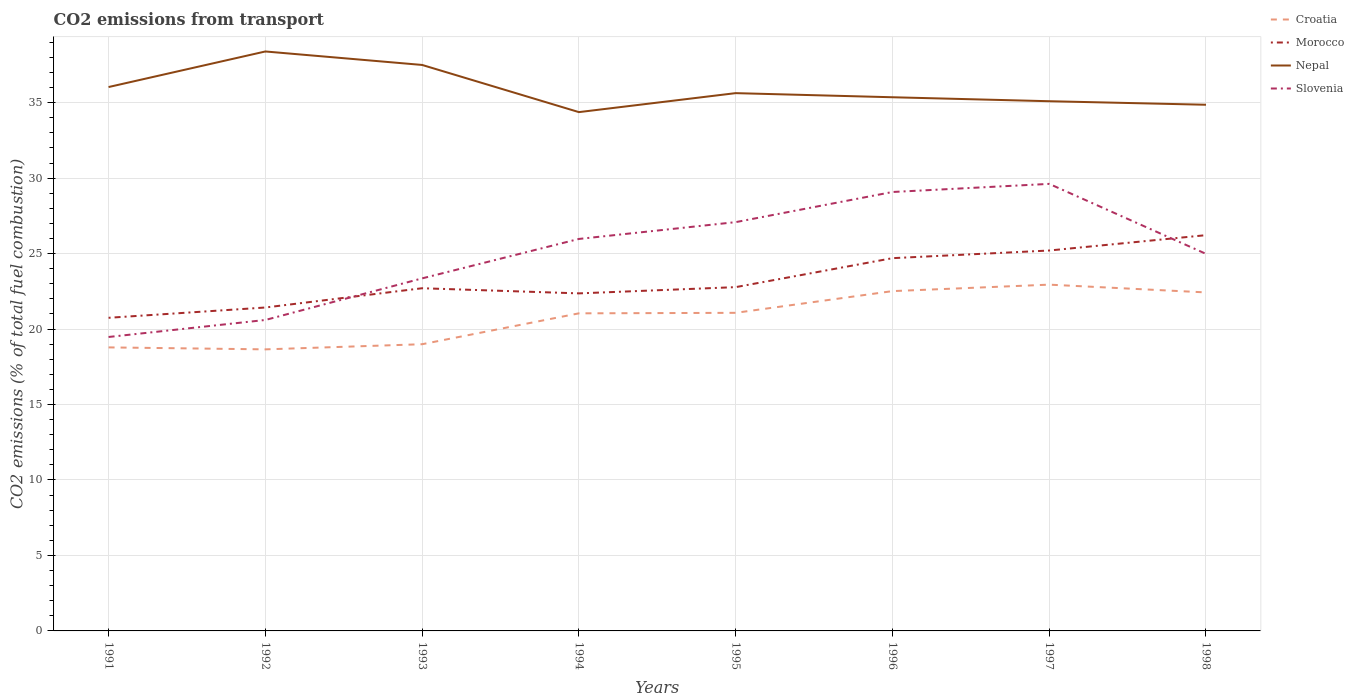How many different coloured lines are there?
Give a very brief answer. 4. Across all years, what is the maximum total CO2 emitted in Slovenia?
Your answer should be compact. 19.48. In which year was the total CO2 emitted in Nepal maximum?
Your response must be concise. 1994. What is the total total CO2 emitted in Morocco in the graph?
Your response must be concise. -1.35. What is the difference between the highest and the second highest total CO2 emitted in Croatia?
Your answer should be very brief. 4.29. Is the total CO2 emitted in Nepal strictly greater than the total CO2 emitted in Slovenia over the years?
Make the answer very short. No. How many lines are there?
Provide a short and direct response. 4. How many years are there in the graph?
Offer a very short reply. 8. Are the values on the major ticks of Y-axis written in scientific E-notation?
Keep it short and to the point. No. Does the graph contain grids?
Offer a very short reply. Yes. How are the legend labels stacked?
Your answer should be compact. Vertical. What is the title of the graph?
Your response must be concise. CO2 emissions from transport. What is the label or title of the Y-axis?
Make the answer very short. CO2 emissions (% of total fuel combustion). What is the CO2 emissions (% of total fuel combustion) in Croatia in 1991?
Offer a terse response. 18.79. What is the CO2 emissions (% of total fuel combustion) of Morocco in 1991?
Your answer should be very brief. 20.75. What is the CO2 emissions (% of total fuel combustion) of Nepal in 1991?
Make the answer very short. 36.04. What is the CO2 emissions (% of total fuel combustion) in Slovenia in 1991?
Provide a succinct answer. 19.48. What is the CO2 emissions (% of total fuel combustion) in Croatia in 1992?
Offer a very short reply. 18.66. What is the CO2 emissions (% of total fuel combustion) in Morocco in 1992?
Offer a very short reply. 21.43. What is the CO2 emissions (% of total fuel combustion) in Nepal in 1992?
Your answer should be compact. 38.39. What is the CO2 emissions (% of total fuel combustion) in Slovenia in 1992?
Keep it short and to the point. 20.6. What is the CO2 emissions (% of total fuel combustion) in Croatia in 1993?
Provide a short and direct response. 19. What is the CO2 emissions (% of total fuel combustion) of Morocco in 1993?
Your response must be concise. 22.71. What is the CO2 emissions (% of total fuel combustion) in Nepal in 1993?
Offer a very short reply. 37.5. What is the CO2 emissions (% of total fuel combustion) of Slovenia in 1993?
Make the answer very short. 23.36. What is the CO2 emissions (% of total fuel combustion) in Croatia in 1994?
Provide a succinct answer. 21.04. What is the CO2 emissions (% of total fuel combustion) in Morocco in 1994?
Keep it short and to the point. 22.36. What is the CO2 emissions (% of total fuel combustion) of Nepal in 1994?
Offer a terse response. 34.38. What is the CO2 emissions (% of total fuel combustion) of Slovenia in 1994?
Offer a terse response. 25.97. What is the CO2 emissions (% of total fuel combustion) of Croatia in 1995?
Provide a succinct answer. 21.08. What is the CO2 emissions (% of total fuel combustion) in Morocco in 1995?
Offer a terse response. 22.78. What is the CO2 emissions (% of total fuel combustion) of Nepal in 1995?
Give a very brief answer. 35.63. What is the CO2 emissions (% of total fuel combustion) of Slovenia in 1995?
Give a very brief answer. 27.08. What is the CO2 emissions (% of total fuel combustion) of Croatia in 1996?
Keep it short and to the point. 22.51. What is the CO2 emissions (% of total fuel combustion) in Morocco in 1996?
Your response must be concise. 24.7. What is the CO2 emissions (% of total fuel combustion) in Nepal in 1996?
Provide a short and direct response. 35.36. What is the CO2 emissions (% of total fuel combustion) in Slovenia in 1996?
Provide a succinct answer. 29.08. What is the CO2 emissions (% of total fuel combustion) of Croatia in 1997?
Ensure brevity in your answer.  22.94. What is the CO2 emissions (% of total fuel combustion) in Morocco in 1997?
Keep it short and to the point. 25.21. What is the CO2 emissions (% of total fuel combustion) of Nepal in 1997?
Offer a terse response. 35.1. What is the CO2 emissions (% of total fuel combustion) of Slovenia in 1997?
Offer a very short reply. 29.62. What is the CO2 emissions (% of total fuel combustion) in Croatia in 1998?
Give a very brief answer. 22.43. What is the CO2 emissions (% of total fuel combustion) of Morocco in 1998?
Ensure brevity in your answer.  26.22. What is the CO2 emissions (% of total fuel combustion) of Nepal in 1998?
Provide a succinct answer. 34.86. What is the CO2 emissions (% of total fuel combustion) in Slovenia in 1998?
Make the answer very short. 24.98. Across all years, what is the maximum CO2 emissions (% of total fuel combustion) in Croatia?
Keep it short and to the point. 22.94. Across all years, what is the maximum CO2 emissions (% of total fuel combustion) of Morocco?
Offer a very short reply. 26.22. Across all years, what is the maximum CO2 emissions (% of total fuel combustion) of Nepal?
Ensure brevity in your answer.  38.39. Across all years, what is the maximum CO2 emissions (% of total fuel combustion) in Slovenia?
Provide a short and direct response. 29.62. Across all years, what is the minimum CO2 emissions (% of total fuel combustion) of Croatia?
Your response must be concise. 18.66. Across all years, what is the minimum CO2 emissions (% of total fuel combustion) in Morocco?
Offer a very short reply. 20.75. Across all years, what is the minimum CO2 emissions (% of total fuel combustion) in Nepal?
Make the answer very short. 34.38. Across all years, what is the minimum CO2 emissions (% of total fuel combustion) in Slovenia?
Offer a terse response. 19.48. What is the total CO2 emissions (% of total fuel combustion) in Croatia in the graph?
Provide a succinct answer. 166.44. What is the total CO2 emissions (% of total fuel combustion) in Morocco in the graph?
Provide a short and direct response. 186.15. What is the total CO2 emissions (% of total fuel combustion) in Nepal in the graph?
Offer a very short reply. 287.25. What is the total CO2 emissions (% of total fuel combustion) of Slovenia in the graph?
Offer a terse response. 200.18. What is the difference between the CO2 emissions (% of total fuel combustion) in Croatia in 1991 and that in 1992?
Keep it short and to the point. 0.13. What is the difference between the CO2 emissions (% of total fuel combustion) in Morocco in 1991 and that in 1992?
Keep it short and to the point. -0.68. What is the difference between the CO2 emissions (% of total fuel combustion) of Nepal in 1991 and that in 1992?
Make the answer very short. -2.36. What is the difference between the CO2 emissions (% of total fuel combustion) of Slovenia in 1991 and that in 1992?
Provide a succinct answer. -1.13. What is the difference between the CO2 emissions (% of total fuel combustion) of Croatia in 1991 and that in 1993?
Your response must be concise. -0.21. What is the difference between the CO2 emissions (% of total fuel combustion) in Morocco in 1991 and that in 1993?
Your answer should be very brief. -1.96. What is the difference between the CO2 emissions (% of total fuel combustion) in Nepal in 1991 and that in 1993?
Make the answer very short. -1.46. What is the difference between the CO2 emissions (% of total fuel combustion) of Slovenia in 1991 and that in 1993?
Give a very brief answer. -3.88. What is the difference between the CO2 emissions (% of total fuel combustion) of Croatia in 1991 and that in 1994?
Ensure brevity in your answer.  -2.26. What is the difference between the CO2 emissions (% of total fuel combustion) of Morocco in 1991 and that in 1994?
Keep it short and to the point. -1.62. What is the difference between the CO2 emissions (% of total fuel combustion) of Nepal in 1991 and that in 1994?
Provide a succinct answer. 1.66. What is the difference between the CO2 emissions (% of total fuel combustion) of Slovenia in 1991 and that in 1994?
Offer a terse response. -6.5. What is the difference between the CO2 emissions (% of total fuel combustion) in Croatia in 1991 and that in 1995?
Make the answer very short. -2.29. What is the difference between the CO2 emissions (% of total fuel combustion) in Morocco in 1991 and that in 1995?
Your answer should be compact. -2.03. What is the difference between the CO2 emissions (% of total fuel combustion) of Nepal in 1991 and that in 1995?
Make the answer very short. 0.4. What is the difference between the CO2 emissions (% of total fuel combustion) of Slovenia in 1991 and that in 1995?
Provide a succinct answer. -7.61. What is the difference between the CO2 emissions (% of total fuel combustion) in Croatia in 1991 and that in 1996?
Offer a terse response. -3.73. What is the difference between the CO2 emissions (% of total fuel combustion) in Morocco in 1991 and that in 1996?
Provide a short and direct response. -3.95. What is the difference between the CO2 emissions (% of total fuel combustion) in Nepal in 1991 and that in 1996?
Provide a succinct answer. 0.68. What is the difference between the CO2 emissions (% of total fuel combustion) of Slovenia in 1991 and that in 1996?
Make the answer very short. -9.61. What is the difference between the CO2 emissions (% of total fuel combustion) in Croatia in 1991 and that in 1997?
Offer a terse response. -4.16. What is the difference between the CO2 emissions (% of total fuel combustion) in Morocco in 1991 and that in 1997?
Give a very brief answer. -4.46. What is the difference between the CO2 emissions (% of total fuel combustion) in Nepal in 1991 and that in 1997?
Keep it short and to the point. 0.94. What is the difference between the CO2 emissions (% of total fuel combustion) of Slovenia in 1991 and that in 1997?
Your answer should be compact. -10.14. What is the difference between the CO2 emissions (% of total fuel combustion) in Croatia in 1991 and that in 1998?
Your answer should be compact. -3.64. What is the difference between the CO2 emissions (% of total fuel combustion) in Morocco in 1991 and that in 1998?
Make the answer very short. -5.48. What is the difference between the CO2 emissions (% of total fuel combustion) of Nepal in 1991 and that in 1998?
Make the answer very short. 1.17. What is the difference between the CO2 emissions (% of total fuel combustion) in Slovenia in 1991 and that in 1998?
Provide a succinct answer. -5.51. What is the difference between the CO2 emissions (% of total fuel combustion) in Croatia in 1992 and that in 1993?
Offer a very short reply. -0.34. What is the difference between the CO2 emissions (% of total fuel combustion) of Morocco in 1992 and that in 1993?
Your answer should be compact. -1.28. What is the difference between the CO2 emissions (% of total fuel combustion) in Nepal in 1992 and that in 1993?
Your response must be concise. 0.89. What is the difference between the CO2 emissions (% of total fuel combustion) of Slovenia in 1992 and that in 1993?
Make the answer very short. -2.76. What is the difference between the CO2 emissions (% of total fuel combustion) in Croatia in 1992 and that in 1994?
Make the answer very short. -2.39. What is the difference between the CO2 emissions (% of total fuel combustion) of Morocco in 1992 and that in 1994?
Your response must be concise. -0.94. What is the difference between the CO2 emissions (% of total fuel combustion) of Nepal in 1992 and that in 1994?
Provide a short and direct response. 4.02. What is the difference between the CO2 emissions (% of total fuel combustion) of Slovenia in 1992 and that in 1994?
Give a very brief answer. -5.37. What is the difference between the CO2 emissions (% of total fuel combustion) in Croatia in 1992 and that in 1995?
Offer a terse response. -2.42. What is the difference between the CO2 emissions (% of total fuel combustion) in Morocco in 1992 and that in 1995?
Offer a very short reply. -1.35. What is the difference between the CO2 emissions (% of total fuel combustion) in Nepal in 1992 and that in 1995?
Make the answer very short. 2.76. What is the difference between the CO2 emissions (% of total fuel combustion) of Slovenia in 1992 and that in 1995?
Offer a terse response. -6.48. What is the difference between the CO2 emissions (% of total fuel combustion) in Croatia in 1992 and that in 1996?
Provide a succinct answer. -3.86. What is the difference between the CO2 emissions (% of total fuel combustion) of Morocco in 1992 and that in 1996?
Offer a very short reply. -3.27. What is the difference between the CO2 emissions (% of total fuel combustion) of Nepal in 1992 and that in 1996?
Your answer should be very brief. 3.03. What is the difference between the CO2 emissions (% of total fuel combustion) in Slovenia in 1992 and that in 1996?
Your answer should be very brief. -8.48. What is the difference between the CO2 emissions (% of total fuel combustion) in Croatia in 1992 and that in 1997?
Provide a succinct answer. -4.29. What is the difference between the CO2 emissions (% of total fuel combustion) in Morocco in 1992 and that in 1997?
Your answer should be very brief. -3.78. What is the difference between the CO2 emissions (% of total fuel combustion) of Nepal in 1992 and that in 1997?
Give a very brief answer. 3.3. What is the difference between the CO2 emissions (% of total fuel combustion) in Slovenia in 1992 and that in 1997?
Make the answer very short. -9.02. What is the difference between the CO2 emissions (% of total fuel combustion) in Croatia in 1992 and that in 1998?
Provide a succinct answer. -3.77. What is the difference between the CO2 emissions (% of total fuel combustion) in Morocco in 1992 and that in 1998?
Keep it short and to the point. -4.79. What is the difference between the CO2 emissions (% of total fuel combustion) of Nepal in 1992 and that in 1998?
Offer a very short reply. 3.53. What is the difference between the CO2 emissions (% of total fuel combustion) in Slovenia in 1992 and that in 1998?
Give a very brief answer. -4.38. What is the difference between the CO2 emissions (% of total fuel combustion) of Croatia in 1993 and that in 1994?
Provide a succinct answer. -2.05. What is the difference between the CO2 emissions (% of total fuel combustion) in Morocco in 1993 and that in 1994?
Offer a terse response. 0.34. What is the difference between the CO2 emissions (% of total fuel combustion) of Nepal in 1993 and that in 1994?
Make the answer very short. 3.12. What is the difference between the CO2 emissions (% of total fuel combustion) of Slovenia in 1993 and that in 1994?
Give a very brief answer. -2.61. What is the difference between the CO2 emissions (% of total fuel combustion) of Croatia in 1993 and that in 1995?
Make the answer very short. -2.08. What is the difference between the CO2 emissions (% of total fuel combustion) of Morocco in 1993 and that in 1995?
Keep it short and to the point. -0.07. What is the difference between the CO2 emissions (% of total fuel combustion) in Nepal in 1993 and that in 1995?
Make the answer very short. 1.87. What is the difference between the CO2 emissions (% of total fuel combustion) in Slovenia in 1993 and that in 1995?
Your answer should be very brief. -3.73. What is the difference between the CO2 emissions (% of total fuel combustion) in Croatia in 1993 and that in 1996?
Your answer should be very brief. -3.52. What is the difference between the CO2 emissions (% of total fuel combustion) in Morocco in 1993 and that in 1996?
Give a very brief answer. -1.99. What is the difference between the CO2 emissions (% of total fuel combustion) in Nepal in 1993 and that in 1996?
Offer a very short reply. 2.14. What is the difference between the CO2 emissions (% of total fuel combustion) in Slovenia in 1993 and that in 1996?
Provide a succinct answer. -5.72. What is the difference between the CO2 emissions (% of total fuel combustion) of Croatia in 1993 and that in 1997?
Offer a terse response. -3.95. What is the difference between the CO2 emissions (% of total fuel combustion) of Morocco in 1993 and that in 1997?
Make the answer very short. -2.5. What is the difference between the CO2 emissions (% of total fuel combustion) of Nepal in 1993 and that in 1997?
Provide a succinct answer. 2.4. What is the difference between the CO2 emissions (% of total fuel combustion) in Slovenia in 1993 and that in 1997?
Give a very brief answer. -6.26. What is the difference between the CO2 emissions (% of total fuel combustion) in Croatia in 1993 and that in 1998?
Your answer should be compact. -3.43. What is the difference between the CO2 emissions (% of total fuel combustion) of Morocco in 1993 and that in 1998?
Your response must be concise. -3.52. What is the difference between the CO2 emissions (% of total fuel combustion) in Nepal in 1993 and that in 1998?
Provide a short and direct response. 2.64. What is the difference between the CO2 emissions (% of total fuel combustion) of Slovenia in 1993 and that in 1998?
Your answer should be very brief. -1.62. What is the difference between the CO2 emissions (% of total fuel combustion) in Croatia in 1994 and that in 1995?
Offer a very short reply. -0.03. What is the difference between the CO2 emissions (% of total fuel combustion) in Morocco in 1994 and that in 1995?
Offer a terse response. -0.41. What is the difference between the CO2 emissions (% of total fuel combustion) of Nepal in 1994 and that in 1995?
Give a very brief answer. -1.26. What is the difference between the CO2 emissions (% of total fuel combustion) of Slovenia in 1994 and that in 1995?
Offer a terse response. -1.11. What is the difference between the CO2 emissions (% of total fuel combustion) of Croatia in 1994 and that in 1996?
Give a very brief answer. -1.47. What is the difference between the CO2 emissions (% of total fuel combustion) of Morocco in 1994 and that in 1996?
Offer a very short reply. -2.33. What is the difference between the CO2 emissions (% of total fuel combustion) of Nepal in 1994 and that in 1996?
Ensure brevity in your answer.  -0.98. What is the difference between the CO2 emissions (% of total fuel combustion) in Slovenia in 1994 and that in 1996?
Provide a succinct answer. -3.11. What is the difference between the CO2 emissions (% of total fuel combustion) of Croatia in 1994 and that in 1997?
Provide a short and direct response. -1.9. What is the difference between the CO2 emissions (% of total fuel combustion) of Morocco in 1994 and that in 1997?
Your answer should be very brief. -2.84. What is the difference between the CO2 emissions (% of total fuel combustion) in Nepal in 1994 and that in 1997?
Give a very brief answer. -0.72. What is the difference between the CO2 emissions (% of total fuel combustion) of Slovenia in 1994 and that in 1997?
Your answer should be very brief. -3.65. What is the difference between the CO2 emissions (% of total fuel combustion) of Croatia in 1994 and that in 1998?
Offer a very short reply. -1.39. What is the difference between the CO2 emissions (% of total fuel combustion) of Morocco in 1994 and that in 1998?
Your answer should be very brief. -3.86. What is the difference between the CO2 emissions (% of total fuel combustion) in Nepal in 1994 and that in 1998?
Your answer should be very brief. -0.49. What is the difference between the CO2 emissions (% of total fuel combustion) of Croatia in 1995 and that in 1996?
Provide a short and direct response. -1.44. What is the difference between the CO2 emissions (% of total fuel combustion) of Morocco in 1995 and that in 1996?
Provide a short and direct response. -1.92. What is the difference between the CO2 emissions (% of total fuel combustion) in Nepal in 1995 and that in 1996?
Give a very brief answer. 0.27. What is the difference between the CO2 emissions (% of total fuel combustion) of Slovenia in 1995 and that in 1996?
Your answer should be very brief. -2. What is the difference between the CO2 emissions (% of total fuel combustion) in Croatia in 1995 and that in 1997?
Your answer should be very brief. -1.87. What is the difference between the CO2 emissions (% of total fuel combustion) of Morocco in 1995 and that in 1997?
Provide a succinct answer. -2.43. What is the difference between the CO2 emissions (% of total fuel combustion) in Nepal in 1995 and that in 1997?
Provide a short and direct response. 0.54. What is the difference between the CO2 emissions (% of total fuel combustion) in Slovenia in 1995 and that in 1997?
Provide a short and direct response. -2.54. What is the difference between the CO2 emissions (% of total fuel combustion) in Croatia in 1995 and that in 1998?
Give a very brief answer. -1.35. What is the difference between the CO2 emissions (% of total fuel combustion) in Morocco in 1995 and that in 1998?
Your answer should be compact. -3.44. What is the difference between the CO2 emissions (% of total fuel combustion) in Nepal in 1995 and that in 1998?
Provide a short and direct response. 0.77. What is the difference between the CO2 emissions (% of total fuel combustion) of Slovenia in 1995 and that in 1998?
Keep it short and to the point. 2.1. What is the difference between the CO2 emissions (% of total fuel combustion) in Croatia in 1996 and that in 1997?
Your answer should be very brief. -0.43. What is the difference between the CO2 emissions (% of total fuel combustion) in Morocco in 1996 and that in 1997?
Provide a short and direct response. -0.51. What is the difference between the CO2 emissions (% of total fuel combustion) in Nepal in 1996 and that in 1997?
Keep it short and to the point. 0.26. What is the difference between the CO2 emissions (% of total fuel combustion) in Slovenia in 1996 and that in 1997?
Provide a succinct answer. -0.54. What is the difference between the CO2 emissions (% of total fuel combustion) of Croatia in 1996 and that in 1998?
Give a very brief answer. 0.09. What is the difference between the CO2 emissions (% of total fuel combustion) in Morocco in 1996 and that in 1998?
Your answer should be very brief. -1.52. What is the difference between the CO2 emissions (% of total fuel combustion) in Nepal in 1996 and that in 1998?
Offer a terse response. 0.5. What is the difference between the CO2 emissions (% of total fuel combustion) in Slovenia in 1996 and that in 1998?
Your answer should be compact. 4.1. What is the difference between the CO2 emissions (% of total fuel combustion) of Croatia in 1997 and that in 1998?
Ensure brevity in your answer.  0.52. What is the difference between the CO2 emissions (% of total fuel combustion) in Morocco in 1997 and that in 1998?
Offer a terse response. -1.02. What is the difference between the CO2 emissions (% of total fuel combustion) of Nepal in 1997 and that in 1998?
Offer a terse response. 0.23. What is the difference between the CO2 emissions (% of total fuel combustion) in Slovenia in 1997 and that in 1998?
Ensure brevity in your answer.  4.64. What is the difference between the CO2 emissions (% of total fuel combustion) of Croatia in 1991 and the CO2 emissions (% of total fuel combustion) of Morocco in 1992?
Make the answer very short. -2.64. What is the difference between the CO2 emissions (% of total fuel combustion) of Croatia in 1991 and the CO2 emissions (% of total fuel combustion) of Nepal in 1992?
Offer a very short reply. -19.61. What is the difference between the CO2 emissions (% of total fuel combustion) in Croatia in 1991 and the CO2 emissions (% of total fuel combustion) in Slovenia in 1992?
Your response must be concise. -1.82. What is the difference between the CO2 emissions (% of total fuel combustion) of Morocco in 1991 and the CO2 emissions (% of total fuel combustion) of Nepal in 1992?
Keep it short and to the point. -17.65. What is the difference between the CO2 emissions (% of total fuel combustion) of Morocco in 1991 and the CO2 emissions (% of total fuel combustion) of Slovenia in 1992?
Offer a terse response. 0.14. What is the difference between the CO2 emissions (% of total fuel combustion) in Nepal in 1991 and the CO2 emissions (% of total fuel combustion) in Slovenia in 1992?
Provide a short and direct response. 15.43. What is the difference between the CO2 emissions (% of total fuel combustion) in Croatia in 1991 and the CO2 emissions (% of total fuel combustion) in Morocco in 1993?
Your answer should be compact. -3.92. What is the difference between the CO2 emissions (% of total fuel combustion) of Croatia in 1991 and the CO2 emissions (% of total fuel combustion) of Nepal in 1993?
Make the answer very short. -18.71. What is the difference between the CO2 emissions (% of total fuel combustion) in Croatia in 1991 and the CO2 emissions (% of total fuel combustion) in Slovenia in 1993?
Ensure brevity in your answer.  -4.57. What is the difference between the CO2 emissions (% of total fuel combustion) of Morocco in 1991 and the CO2 emissions (% of total fuel combustion) of Nepal in 1993?
Give a very brief answer. -16.75. What is the difference between the CO2 emissions (% of total fuel combustion) of Morocco in 1991 and the CO2 emissions (% of total fuel combustion) of Slovenia in 1993?
Your response must be concise. -2.61. What is the difference between the CO2 emissions (% of total fuel combustion) in Nepal in 1991 and the CO2 emissions (% of total fuel combustion) in Slovenia in 1993?
Your answer should be compact. 12.68. What is the difference between the CO2 emissions (% of total fuel combustion) of Croatia in 1991 and the CO2 emissions (% of total fuel combustion) of Morocco in 1994?
Provide a short and direct response. -3.58. What is the difference between the CO2 emissions (% of total fuel combustion) in Croatia in 1991 and the CO2 emissions (% of total fuel combustion) in Nepal in 1994?
Offer a very short reply. -15.59. What is the difference between the CO2 emissions (% of total fuel combustion) of Croatia in 1991 and the CO2 emissions (% of total fuel combustion) of Slovenia in 1994?
Offer a very short reply. -7.19. What is the difference between the CO2 emissions (% of total fuel combustion) in Morocco in 1991 and the CO2 emissions (% of total fuel combustion) in Nepal in 1994?
Keep it short and to the point. -13.63. What is the difference between the CO2 emissions (% of total fuel combustion) of Morocco in 1991 and the CO2 emissions (% of total fuel combustion) of Slovenia in 1994?
Make the answer very short. -5.22. What is the difference between the CO2 emissions (% of total fuel combustion) of Nepal in 1991 and the CO2 emissions (% of total fuel combustion) of Slovenia in 1994?
Give a very brief answer. 10.06. What is the difference between the CO2 emissions (% of total fuel combustion) of Croatia in 1991 and the CO2 emissions (% of total fuel combustion) of Morocco in 1995?
Provide a short and direct response. -3.99. What is the difference between the CO2 emissions (% of total fuel combustion) of Croatia in 1991 and the CO2 emissions (% of total fuel combustion) of Nepal in 1995?
Offer a very short reply. -16.85. What is the difference between the CO2 emissions (% of total fuel combustion) of Croatia in 1991 and the CO2 emissions (% of total fuel combustion) of Slovenia in 1995?
Offer a very short reply. -8.3. What is the difference between the CO2 emissions (% of total fuel combustion) in Morocco in 1991 and the CO2 emissions (% of total fuel combustion) in Nepal in 1995?
Make the answer very short. -14.89. What is the difference between the CO2 emissions (% of total fuel combustion) of Morocco in 1991 and the CO2 emissions (% of total fuel combustion) of Slovenia in 1995?
Your response must be concise. -6.34. What is the difference between the CO2 emissions (% of total fuel combustion) in Nepal in 1991 and the CO2 emissions (% of total fuel combustion) in Slovenia in 1995?
Keep it short and to the point. 8.95. What is the difference between the CO2 emissions (% of total fuel combustion) of Croatia in 1991 and the CO2 emissions (% of total fuel combustion) of Morocco in 1996?
Give a very brief answer. -5.91. What is the difference between the CO2 emissions (% of total fuel combustion) of Croatia in 1991 and the CO2 emissions (% of total fuel combustion) of Nepal in 1996?
Provide a succinct answer. -16.57. What is the difference between the CO2 emissions (% of total fuel combustion) of Croatia in 1991 and the CO2 emissions (% of total fuel combustion) of Slovenia in 1996?
Provide a succinct answer. -10.3. What is the difference between the CO2 emissions (% of total fuel combustion) in Morocco in 1991 and the CO2 emissions (% of total fuel combustion) in Nepal in 1996?
Your response must be concise. -14.61. What is the difference between the CO2 emissions (% of total fuel combustion) of Morocco in 1991 and the CO2 emissions (% of total fuel combustion) of Slovenia in 1996?
Make the answer very short. -8.34. What is the difference between the CO2 emissions (% of total fuel combustion) of Nepal in 1991 and the CO2 emissions (% of total fuel combustion) of Slovenia in 1996?
Offer a terse response. 6.95. What is the difference between the CO2 emissions (% of total fuel combustion) in Croatia in 1991 and the CO2 emissions (% of total fuel combustion) in Morocco in 1997?
Your answer should be compact. -6.42. What is the difference between the CO2 emissions (% of total fuel combustion) of Croatia in 1991 and the CO2 emissions (% of total fuel combustion) of Nepal in 1997?
Your response must be concise. -16.31. What is the difference between the CO2 emissions (% of total fuel combustion) in Croatia in 1991 and the CO2 emissions (% of total fuel combustion) in Slovenia in 1997?
Offer a terse response. -10.83. What is the difference between the CO2 emissions (% of total fuel combustion) of Morocco in 1991 and the CO2 emissions (% of total fuel combustion) of Nepal in 1997?
Provide a succinct answer. -14.35. What is the difference between the CO2 emissions (% of total fuel combustion) of Morocco in 1991 and the CO2 emissions (% of total fuel combustion) of Slovenia in 1997?
Offer a terse response. -8.87. What is the difference between the CO2 emissions (% of total fuel combustion) of Nepal in 1991 and the CO2 emissions (% of total fuel combustion) of Slovenia in 1997?
Your response must be concise. 6.42. What is the difference between the CO2 emissions (% of total fuel combustion) in Croatia in 1991 and the CO2 emissions (% of total fuel combustion) in Morocco in 1998?
Keep it short and to the point. -7.44. What is the difference between the CO2 emissions (% of total fuel combustion) of Croatia in 1991 and the CO2 emissions (% of total fuel combustion) of Nepal in 1998?
Keep it short and to the point. -16.08. What is the difference between the CO2 emissions (% of total fuel combustion) in Croatia in 1991 and the CO2 emissions (% of total fuel combustion) in Slovenia in 1998?
Keep it short and to the point. -6.2. What is the difference between the CO2 emissions (% of total fuel combustion) of Morocco in 1991 and the CO2 emissions (% of total fuel combustion) of Nepal in 1998?
Give a very brief answer. -14.12. What is the difference between the CO2 emissions (% of total fuel combustion) in Morocco in 1991 and the CO2 emissions (% of total fuel combustion) in Slovenia in 1998?
Keep it short and to the point. -4.24. What is the difference between the CO2 emissions (% of total fuel combustion) of Nepal in 1991 and the CO2 emissions (% of total fuel combustion) of Slovenia in 1998?
Make the answer very short. 11.05. What is the difference between the CO2 emissions (% of total fuel combustion) of Croatia in 1992 and the CO2 emissions (% of total fuel combustion) of Morocco in 1993?
Your response must be concise. -4.05. What is the difference between the CO2 emissions (% of total fuel combustion) of Croatia in 1992 and the CO2 emissions (% of total fuel combustion) of Nepal in 1993?
Your answer should be very brief. -18.84. What is the difference between the CO2 emissions (% of total fuel combustion) in Croatia in 1992 and the CO2 emissions (% of total fuel combustion) in Slovenia in 1993?
Keep it short and to the point. -4.7. What is the difference between the CO2 emissions (% of total fuel combustion) in Morocco in 1992 and the CO2 emissions (% of total fuel combustion) in Nepal in 1993?
Your answer should be very brief. -16.07. What is the difference between the CO2 emissions (% of total fuel combustion) in Morocco in 1992 and the CO2 emissions (% of total fuel combustion) in Slovenia in 1993?
Make the answer very short. -1.93. What is the difference between the CO2 emissions (% of total fuel combustion) of Nepal in 1992 and the CO2 emissions (% of total fuel combustion) of Slovenia in 1993?
Your response must be concise. 15.03. What is the difference between the CO2 emissions (% of total fuel combustion) in Croatia in 1992 and the CO2 emissions (% of total fuel combustion) in Morocco in 1994?
Ensure brevity in your answer.  -3.71. What is the difference between the CO2 emissions (% of total fuel combustion) of Croatia in 1992 and the CO2 emissions (% of total fuel combustion) of Nepal in 1994?
Offer a very short reply. -15.72. What is the difference between the CO2 emissions (% of total fuel combustion) in Croatia in 1992 and the CO2 emissions (% of total fuel combustion) in Slovenia in 1994?
Keep it short and to the point. -7.32. What is the difference between the CO2 emissions (% of total fuel combustion) in Morocco in 1992 and the CO2 emissions (% of total fuel combustion) in Nepal in 1994?
Provide a short and direct response. -12.95. What is the difference between the CO2 emissions (% of total fuel combustion) of Morocco in 1992 and the CO2 emissions (% of total fuel combustion) of Slovenia in 1994?
Provide a succinct answer. -4.54. What is the difference between the CO2 emissions (% of total fuel combustion) in Nepal in 1992 and the CO2 emissions (% of total fuel combustion) in Slovenia in 1994?
Offer a terse response. 12.42. What is the difference between the CO2 emissions (% of total fuel combustion) in Croatia in 1992 and the CO2 emissions (% of total fuel combustion) in Morocco in 1995?
Your answer should be compact. -4.12. What is the difference between the CO2 emissions (% of total fuel combustion) of Croatia in 1992 and the CO2 emissions (% of total fuel combustion) of Nepal in 1995?
Your answer should be compact. -16.98. What is the difference between the CO2 emissions (% of total fuel combustion) in Croatia in 1992 and the CO2 emissions (% of total fuel combustion) in Slovenia in 1995?
Provide a succinct answer. -8.43. What is the difference between the CO2 emissions (% of total fuel combustion) of Morocco in 1992 and the CO2 emissions (% of total fuel combustion) of Nepal in 1995?
Your answer should be very brief. -14.2. What is the difference between the CO2 emissions (% of total fuel combustion) in Morocco in 1992 and the CO2 emissions (% of total fuel combustion) in Slovenia in 1995?
Provide a short and direct response. -5.66. What is the difference between the CO2 emissions (% of total fuel combustion) of Nepal in 1992 and the CO2 emissions (% of total fuel combustion) of Slovenia in 1995?
Your answer should be compact. 11.31. What is the difference between the CO2 emissions (% of total fuel combustion) in Croatia in 1992 and the CO2 emissions (% of total fuel combustion) in Morocco in 1996?
Give a very brief answer. -6.04. What is the difference between the CO2 emissions (% of total fuel combustion) of Croatia in 1992 and the CO2 emissions (% of total fuel combustion) of Nepal in 1996?
Give a very brief answer. -16.7. What is the difference between the CO2 emissions (% of total fuel combustion) in Croatia in 1992 and the CO2 emissions (% of total fuel combustion) in Slovenia in 1996?
Make the answer very short. -10.43. What is the difference between the CO2 emissions (% of total fuel combustion) in Morocco in 1992 and the CO2 emissions (% of total fuel combustion) in Nepal in 1996?
Give a very brief answer. -13.93. What is the difference between the CO2 emissions (% of total fuel combustion) in Morocco in 1992 and the CO2 emissions (% of total fuel combustion) in Slovenia in 1996?
Keep it short and to the point. -7.65. What is the difference between the CO2 emissions (% of total fuel combustion) in Nepal in 1992 and the CO2 emissions (% of total fuel combustion) in Slovenia in 1996?
Give a very brief answer. 9.31. What is the difference between the CO2 emissions (% of total fuel combustion) in Croatia in 1992 and the CO2 emissions (% of total fuel combustion) in Morocco in 1997?
Ensure brevity in your answer.  -6.55. What is the difference between the CO2 emissions (% of total fuel combustion) in Croatia in 1992 and the CO2 emissions (% of total fuel combustion) in Nepal in 1997?
Give a very brief answer. -16.44. What is the difference between the CO2 emissions (% of total fuel combustion) of Croatia in 1992 and the CO2 emissions (% of total fuel combustion) of Slovenia in 1997?
Your response must be concise. -10.96. What is the difference between the CO2 emissions (% of total fuel combustion) in Morocco in 1992 and the CO2 emissions (% of total fuel combustion) in Nepal in 1997?
Your response must be concise. -13.67. What is the difference between the CO2 emissions (% of total fuel combustion) of Morocco in 1992 and the CO2 emissions (% of total fuel combustion) of Slovenia in 1997?
Offer a very short reply. -8.19. What is the difference between the CO2 emissions (% of total fuel combustion) in Nepal in 1992 and the CO2 emissions (% of total fuel combustion) in Slovenia in 1997?
Offer a very short reply. 8.77. What is the difference between the CO2 emissions (% of total fuel combustion) in Croatia in 1992 and the CO2 emissions (% of total fuel combustion) in Morocco in 1998?
Your response must be concise. -7.57. What is the difference between the CO2 emissions (% of total fuel combustion) of Croatia in 1992 and the CO2 emissions (% of total fuel combustion) of Nepal in 1998?
Provide a short and direct response. -16.21. What is the difference between the CO2 emissions (% of total fuel combustion) of Croatia in 1992 and the CO2 emissions (% of total fuel combustion) of Slovenia in 1998?
Your answer should be very brief. -6.33. What is the difference between the CO2 emissions (% of total fuel combustion) in Morocco in 1992 and the CO2 emissions (% of total fuel combustion) in Nepal in 1998?
Make the answer very short. -13.43. What is the difference between the CO2 emissions (% of total fuel combustion) in Morocco in 1992 and the CO2 emissions (% of total fuel combustion) in Slovenia in 1998?
Keep it short and to the point. -3.55. What is the difference between the CO2 emissions (% of total fuel combustion) of Nepal in 1992 and the CO2 emissions (% of total fuel combustion) of Slovenia in 1998?
Keep it short and to the point. 13.41. What is the difference between the CO2 emissions (% of total fuel combustion) of Croatia in 1993 and the CO2 emissions (% of total fuel combustion) of Morocco in 1994?
Your answer should be very brief. -3.37. What is the difference between the CO2 emissions (% of total fuel combustion) in Croatia in 1993 and the CO2 emissions (% of total fuel combustion) in Nepal in 1994?
Offer a terse response. -15.38. What is the difference between the CO2 emissions (% of total fuel combustion) of Croatia in 1993 and the CO2 emissions (% of total fuel combustion) of Slovenia in 1994?
Ensure brevity in your answer.  -6.97. What is the difference between the CO2 emissions (% of total fuel combustion) in Morocco in 1993 and the CO2 emissions (% of total fuel combustion) in Nepal in 1994?
Offer a very short reply. -11.67. What is the difference between the CO2 emissions (% of total fuel combustion) of Morocco in 1993 and the CO2 emissions (% of total fuel combustion) of Slovenia in 1994?
Your answer should be compact. -3.27. What is the difference between the CO2 emissions (% of total fuel combustion) of Nepal in 1993 and the CO2 emissions (% of total fuel combustion) of Slovenia in 1994?
Provide a succinct answer. 11.53. What is the difference between the CO2 emissions (% of total fuel combustion) of Croatia in 1993 and the CO2 emissions (% of total fuel combustion) of Morocco in 1995?
Ensure brevity in your answer.  -3.78. What is the difference between the CO2 emissions (% of total fuel combustion) of Croatia in 1993 and the CO2 emissions (% of total fuel combustion) of Nepal in 1995?
Keep it short and to the point. -16.64. What is the difference between the CO2 emissions (% of total fuel combustion) of Croatia in 1993 and the CO2 emissions (% of total fuel combustion) of Slovenia in 1995?
Keep it short and to the point. -8.09. What is the difference between the CO2 emissions (% of total fuel combustion) in Morocco in 1993 and the CO2 emissions (% of total fuel combustion) in Nepal in 1995?
Your answer should be compact. -12.93. What is the difference between the CO2 emissions (% of total fuel combustion) of Morocco in 1993 and the CO2 emissions (% of total fuel combustion) of Slovenia in 1995?
Provide a succinct answer. -4.38. What is the difference between the CO2 emissions (% of total fuel combustion) in Nepal in 1993 and the CO2 emissions (% of total fuel combustion) in Slovenia in 1995?
Ensure brevity in your answer.  10.42. What is the difference between the CO2 emissions (% of total fuel combustion) of Croatia in 1993 and the CO2 emissions (% of total fuel combustion) of Morocco in 1996?
Your answer should be very brief. -5.7. What is the difference between the CO2 emissions (% of total fuel combustion) of Croatia in 1993 and the CO2 emissions (% of total fuel combustion) of Nepal in 1996?
Provide a succinct answer. -16.36. What is the difference between the CO2 emissions (% of total fuel combustion) in Croatia in 1993 and the CO2 emissions (% of total fuel combustion) in Slovenia in 1996?
Your answer should be compact. -10.09. What is the difference between the CO2 emissions (% of total fuel combustion) in Morocco in 1993 and the CO2 emissions (% of total fuel combustion) in Nepal in 1996?
Ensure brevity in your answer.  -12.65. What is the difference between the CO2 emissions (% of total fuel combustion) of Morocco in 1993 and the CO2 emissions (% of total fuel combustion) of Slovenia in 1996?
Offer a very short reply. -6.38. What is the difference between the CO2 emissions (% of total fuel combustion) of Nepal in 1993 and the CO2 emissions (% of total fuel combustion) of Slovenia in 1996?
Your answer should be compact. 8.42. What is the difference between the CO2 emissions (% of total fuel combustion) of Croatia in 1993 and the CO2 emissions (% of total fuel combustion) of Morocco in 1997?
Give a very brief answer. -6.21. What is the difference between the CO2 emissions (% of total fuel combustion) in Croatia in 1993 and the CO2 emissions (% of total fuel combustion) in Nepal in 1997?
Provide a succinct answer. -16.1. What is the difference between the CO2 emissions (% of total fuel combustion) of Croatia in 1993 and the CO2 emissions (% of total fuel combustion) of Slovenia in 1997?
Provide a succinct answer. -10.62. What is the difference between the CO2 emissions (% of total fuel combustion) in Morocco in 1993 and the CO2 emissions (% of total fuel combustion) in Nepal in 1997?
Provide a short and direct response. -12.39. What is the difference between the CO2 emissions (% of total fuel combustion) of Morocco in 1993 and the CO2 emissions (% of total fuel combustion) of Slovenia in 1997?
Offer a terse response. -6.91. What is the difference between the CO2 emissions (% of total fuel combustion) of Nepal in 1993 and the CO2 emissions (% of total fuel combustion) of Slovenia in 1997?
Provide a succinct answer. 7.88. What is the difference between the CO2 emissions (% of total fuel combustion) of Croatia in 1993 and the CO2 emissions (% of total fuel combustion) of Morocco in 1998?
Keep it short and to the point. -7.23. What is the difference between the CO2 emissions (% of total fuel combustion) in Croatia in 1993 and the CO2 emissions (% of total fuel combustion) in Nepal in 1998?
Keep it short and to the point. -15.87. What is the difference between the CO2 emissions (% of total fuel combustion) in Croatia in 1993 and the CO2 emissions (% of total fuel combustion) in Slovenia in 1998?
Give a very brief answer. -5.99. What is the difference between the CO2 emissions (% of total fuel combustion) in Morocco in 1993 and the CO2 emissions (% of total fuel combustion) in Nepal in 1998?
Your answer should be very brief. -12.16. What is the difference between the CO2 emissions (% of total fuel combustion) in Morocco in 1993 and the CO2 emissions (% of total fuel combustion) in Slovenia in 1998?
Your answer should be very brief. -2.28. What is the difference between the CO2 emissions (% of total fuel combustion) in Nepal in 1993 and the CO2 emissions (% of total fuel combustion) in Slovenia in 1998?
Give a very brief answer. 12.52. What is the difference between the CO2 emissions (% of total fuel combustion) of Croatia in 1994 and the CO2 emissions (% of total fuel combustion) of Morocco in 1995?
Offer a terse response. -1.74. What is the difference between the CO2 emissions (% of total fuel combustion) in Croatia in 1994 and the CO2 emissions (% of total fuel combustion) in Nepal in 1995?
Your answer should be compact. -14.59. What is the difference between the CO2 emissions (% of total fuel combustion) of Croatia in 1994 and the CO2 emissions (% of total fuel combustion) of Slovenia in 1995?
Make the answer very short. -6.04. What is the difference between the CO2 emissions (% of total fuel combustion) in Morocco in 1994 and the CO2 emissions (% of total fuel combustion) in Nepal in 1995?
Provide a succinct answer. -13.27. What is the difference between the CO2 emissions (% of total fuel combustion) of Morocco in 1994 and the CO2 emissions (% of total fuel combustion) of Slovenia in 1995?
Your answer should be compact. -4.72. What is the difference between the CO2 emissions (% of total fuel combustion) of Nepal in 1994 and the CO2 emissions (% of total fuel combustion) of Slovenia in 1995?
Your answer should be compact. 7.29. What is the difference between the CO2 emissions (% of total fuel combustion) in Croatia in 1994 and the CO2 emissions (% of total fuel combustion) in Morocco in 1996?
Give a very brief answer. -3.66. What is the difference between the CO2 emissions (% of total fuel combustion) in Croatia in 1994 and the CO2 emissions (% of total fuel combustion) in Nepal in 1996?
Your answer should be compact. -14.32. What is the difference between the CO2 emissions (% of total fuel combustion) of Croatia in 1994 and the CO2 emissions (% of total fuel combustion) of Slovenia in 1996?
Ensure brevity in your answer.  -8.04. What is the difference between the CO2 emissions (% of total fuel combustion) of Morocco in 1994 and the CO2 emissions (% of total fuel combustion) of Nepal in 1996?
Your answer should be compact. -12.99. What is the difference between the CO2 emissions (% of total fuel combustion) in Morocco in 1994 and the CO2 emissions (% of total fuel combustion) in Slovenia in 1996?
Provide a succinct answer. -6.72. What is the difference between the CO2 emissions (% of total fuel combustion) in Nepal in 1994 and the CO2 emissions (% of total fuel combustion) in Slovenia in 1996?
Your answer should be compact. 5.29. What is the difference between the CO2 emissions (% of total fuel combustion) in Croatia in 1994 and the CO2 emissions (% of total fuel combustion) in Morocco in 1997?
Make the answer very short. -4.16. What is the difference between the CO2 emissions (% of total fuel combustion) in Croatia in 1994 and the CO2 emissions (% of total fuel combustion) in Nepal in 1997?
Provide a succinct answer. -14.05. What is the difference between the CO2 emissions (% of total fuel combustion) of Croatia in 1994 and the CO2 emissions (% of total fuel combustion) of Slovenia in 1997?
Your answer should be compact. -8.58. What is the difference between the CO2 emissions (% of total fuel combustion) in Morocco in 1994 and the CO2 emissions (% of total fuel combustion) in Nepal in 1997?
Your response must be concise. -12.73. What is the difference between the CO2 emissions (% of total fuel combustion) in Morocco in 1994 and the CO2 emissions (% of total fuel combustion) in Slovenia in 1997?
Ensure brevity in your answer.  -7.26. What is the difference between the CO2 emissions (% of total fuel combustion) of Nepal in 1994 and the CO2 emissions (% of total fuel combustion) of Slovenia in 1997?
Ensure brevity in your answer.  4.76. What is the difference between the CO2 emissions (% of total fuel combustion) in Croatia in 1994 and the CO2 emissions (% of total fuel combustion) in Morocco in 1998?
Your answer should be compact. -5.18. What is the difference between the CO2 emissions (% of total fuel combustion) of Croatia in 1994 and the CO2 emissions (% of total fuel combustion) of Nepal in 1998?
Provide a succinct answer. -13.82. What is the difference between the CO2 emissions (% of total fuel combustion) in Croatia in 1994 and the CO2 emissions (% of total fuel combustion) in Slovenia in 1998?
Provide a succinct answer. -3.94. What is the difference between the CO2 emissions (% of total fuel combustion) in Morocco in 1994 and the CO2 emissions (% of total fuel combustion) in Nepal in 1998?
Your answer should be compact. -12.5. What is the difference between the CO2 emissions (% of total fuel combustion) in Morocco in 1994 and the CO2 emissions (% of total fuel combustion) in Slovenia in 1998?
Give a very brief answer. -2.62. What is the difference between the CO2 emissions (% of total fuel combustion) in Nepal in 1994 and the CO2 emissions (% of total fuel combustion) in Slovenia in 1998?
Your response must be concise. 9.39. What is the difference between the CO2 emissions (% of total fuel combustion) of Croatia in 1995 and the CO2 emissions (% of total fuel combustion) of Morocco in 1996?
Provide a short and direct response. -3.62. What is the difference between the CO2 emissions (% of total fuel combustion) of Croatia in 1995 and the CO2 emissions (% of total fuel combustion) of Nepal in 1996?
Your answer should be compact. -14.28. What is the difference between the CO2 emissions (% of total fuel combustion) in Croatia in 1995 and the CO2 emissions (% of total fuel combustion) in Slovenia in 1996?
Your answer should be very brief. -8.01. What is the difference between the CO2 emissions (% of total fuel combustion) in Morocco in 1995 and the CO2 emissions (% of total fuel combustion) in Nepal in 1996?
Offer a very short reply. -12.58. What is the difference between the CO2 emissions (% of total fuel combustion) in Morocco in 1995 and the CO2 emissions (% of total fuel combustion) in Slovenia in 1996?
Offer a terse response. -6.3. What is the difference between the CO2 emissions (% of total fuel combustion) in Nepal in 1995 and the CO2 emissions (% of total fuel combustion) in Slovenia in 1996?
Offer a terse response. 6.55. What is the difference between the CO2 emissions (% of total fuel combustion) in Croatia in 1995 and the CO2 emissions (% of total fuel combustion) in Morocco in 1997?
Keep it short and to the point. -4.13. What is the difference between the CO2 emissions (% of total fuel combustion) of Croatia in 1995 and the CO2 emissions (% of total fuel combustion) of Nepal in 1997?
Your answer should be very brief. -14.02. What is the difference between the CO2 emissions (% of total fuel combustion) of Croatia in 1995 and the CO2 emissions (% of total fuel combustion) of Slovenia in 1997?
Your answer should be very brief. -8.54. What is the difference between the CO2 emissions (% of total fuel combustion) in Morocco in 1995 and the CO2 emissions (% of total fuel combustion) in Nepal in 1997?
Offer a terse response. -12.32. What is the difference between the CO2 emissions (% of total fuel combustion) of Morocco in 1995 and the CO2 emissions (% of total fuel combustion) of Slovenia in 1997?
Offer a very short reply. -6.84. What is the difference between the CO2 emissions (% of total fuel combustion) in Nepal in 1995 and the CO2 emissions (% of total fuel combustion) in Slovenia in 1997?
Your answer should be very brief. 6.01. What is the difference between the CO2 emissions (% of total fuel combustion) in Croatia in 1995 and the CO2 emissions (% of total fuel combustion) in Morocco in 1998?
Offer a terse response. -5.15. What is the difference between the CO2 emissions (% of total fuel combustion) in Croatia in 1995 and the CO2 emissions (% of total fuel combustion) in Nepal in 1998?
Keep it short and to the point. -13.79. What is the difference between the CO2 emissions (% of total fuel combustion) of Croatia in 1995 and the CO2 emissions (% of total fuel combustion) of Slovenia in 1998?
Provide a succinct answer. -3.91. What is the difference between the CO2 emissions (% of total fuel combustion) in Morocco in 1995 and the CO2 emissions (% of total fuel combustion) in Nepal in 1998?
Your answer should be very brief. -12.08. What is the difference between the CO2 emissions (% of total fuel combustion) of Morocco in 1995 and the CO2 emissions (% of total fuel combustion) of Slovenia in 1998?
Your answer should be compact. -2.21. What is the difference between the CO2 emissions (% of total fuel combustion) of Nepal in 1995 and the CO2 emissions (% of total fuel combustion) of Slovenia in 1998?
Make the answer very short. 10.65. What is the difference between the CO2 emissions (% of total fuel combustion) in Croatia in 1996 and the CO2 emissions (% of total fuel combustion) in Morocco in 1997?
Offer a very short reply. -2.69. What is the difference between the CO2 emissions (% of total fuel combustion) of Croatia in 1996 and the CO2 emissions (% of total fuel combustion) of Nepal in 1997?
Ensure brevity in your answer.  -12.58. What is the difference between the CO2 emissions (% of total fuel combustion) of Croatia in 1996 and the CO2 emissions (% of total fuel combustion) of Slovenia in 1997?
Your answer should be compact. -7.11. What is the difference between the CO2 emissions (% of total fuel combustion) of Morocco in 1996 and the CO2 emissions (% of total fuel combustion) of Nepal in 1997?
Your response must be concise. -10.4. What is the difference between the CO2 emissions (% of total fuel combustion) in Morocco in 1996 and the CO2 emissions (% of total fuel combustion) in Slovenia in 1997?
Give a very brief answer. -4.92. What is the difference between the CO2 emissions (% of total fuel combustion) of Nepal in 1996 and the CO2 emissions (% of total fuel combustion) of Slovenia in 1997?
Make the answer very short. 5.74. What is the difference between the CO2 emissions (% of total fuel combustion) of Croatia in 1996 and the CO2 emissions (% of total fuel combustion) of Morocco in 1998?
Offer a terse response. -3.71. What is the difference between the CO2 emissions (% of total fuel combustion) of Croatia in 1996 and the CO2 emissions (% of total fuel combustion) of Nepal in 1998?
Keep it short and to the point. -12.35. What is the difference between the CO2 emissions (% of total fuel combustion) in Croatia in 1996 and the CO2 emissions (% of total fuel combustion) in Slovenia in 1998?
Your answer should be very brief. -2.47. What is the difference between the CO2 emissions (% of total fuel combustion) in Morocco in 1996 and the CO2 emissions (% of total fuel combustion) in Nepal in 1998?
Offer a very short reply. -10.16. What is the difference between the CO2 emissions (% of total fuel combustion) in Morocco in 1996 and the CO2 emissions (% of total fuel combustion) in Slovenia in 1998?
Provide a succinct answer. -0.29. What is the difference between the CO2 emissions (% of total fuel combustion) of Nepal in 1996 and the CO2 emissions (% of total fuel combustion) of Slovenia in 1998?
Offer a very short reply. 10.38. What is the difference between the CO2 emissions (% of total fuel combustion) in Croatia in 1997 and the CO2 emissions (% of total fuel combustion) in Morocco in 1998?
Make the answer very short. -3.28. What is the difference between the CO2 emissions (% of total fuel combustion) of Croatia in 1997 and the CO2 emissions (% of total fuel combustion) of Nepal in 1998?
Your response must be concise. -11.92. What is the difference between the CO2 emissions (% of total fuel combustion) in Croatia in 1997 and the CO2 emissions (% of total fuel combustion) in Slovenia in 1998?
Your answer should be very brief. -2.04. What is the difference between the CO2 emissions (% of total fuel combustion) in Morocco in 1997 and the CO2 emissions (% of total fuel combustion) in Nepal in 1998?
Keep it short and to the point. -9.66. What is the difference between the CO2 emissions (% of total fuel combustion) in Morocco in 1997 and the CO2 emissions (% of total fuel combustion) in Slovenia in 1998?
Make the answer very short. 0.22. What is the difference between the CO2 emissions (% of total fuel combustion) of Nepal in 1997 and the CO2 emissions (% of total fuel combustion) of Slovenia in 1998?
Your response must be concise. 10.11. What is the average CO2 emissions (% of total fuel combustion) of Croatia per year?
Your response must be concise. 20.81. What is the average CO2 emissions (% of total fuel combustion) in Morocco per year?
Make the answer very short. 23.27. What is the average CO2 emissions (% of total fuel combustion) of Nepal per year?
Provide a short and direct response. 35.91. What is the average CO2 emissions (% of total fuel combustion) in Slovenia per year?
Keep it short and to the point. 25.02. In the year 1991, what is the difference between the CO2 emissions (% of total fuel combustion) in Croatia and CO2 emissions (% of total fuel combustion) in Morocco?
Ensure brevity in your answer.  -1.96. In the year 1991, what is the difference between the CO2 emissions (% of total fuel combustion) in Croatia and CO2 emissions (% of total fuel combustion) in Nepal?
Give a very brief answer. -17.25. In the year 1991, what is the difference between the CO2 emissions (% of total fuel combustion) in Croatia and CO2 emissions (% of total fuel combustion) in Slovenia?
Provide a short and direct response. -0.69. In the year 1991, what is the difference between the CO2 emissions (% of total fuel combustion) of Morocco and CO2 emissions (% of total fuel combustion) of Nepal?
Provide a short and direct response. -15.29. In the year 1991, what is the difference between the CO2 emissions (% of total fuel combustion) in Morocco and CO2 emissions (% of total fuel combustion) in Slovenia?
Your response must be concise. 1.27. In the year 1991, what is the difference between the CO2 emissions (% of total fuel combustion) in Nepal and CO2 emissions (% of total fuel combustion) in Slovenia?
Offer a very short reply. 16.56. In the year 1992, what is the difference between the CO2 emissions (% of total fuel combustion) in Croatia and CO2 emissions (% of total fuel combustion) in Morocco?
Your answer should be compact. -2.77. In the year 1992, what is the difference between the CO2 emissions (% of total fuel combustion) of Croatia and CO2 emissions (% of total fuel combustion) of Nepal?
Offer a very short reply. -19.74. In the year 1992, what is the difference between the CO2 emissions (% of total fuel combustion) of Croatia and CO2 emissions (% of total fuel combustion) of Slovenia?
Offer a very short reply. -1.95. In the year 1992, what is the difference between the CO2 emissions (% of total fuel combustion) of Morocco and CO2 emissions (% of total fuel combustion) of Nepal?
Your answer should be compact. -16.96. In the year 1992, what is the difference between the CO2 emissions (% of total fuel combustion) in Morocco and CO2 emissions (% of total fuel combustion) in Slovenia?
Your answer should be compact. 0.83. In the year 1992, what is the difference between the CO2 emissions (% of total fuel combustion) in Nepal and CO2 emissions (% of total fuel combustion) in Slovenia?
Offer a very short reply. 17.79. In the year 1993, what is the difference between the CO2 emissions (% of total fuel combustion) in Croatia and CO2 emissions (% of total fuel combustion) in Morocco?
Ensure brevity in your answer.  -3.71. In the year 1993, what is the difference between the CO2 emissions (% of total fuel combustion) in Croatia and CO2 emissions (% of total fuel combustion) in Nepal?
Offer a terse response. -18.5. In the year 1993, what is the difference between the CO2 emissions (% of total fuel combustion) in Croatia and CO2 emissions (% of total fuel combustion) in Slovenia?
Your answer should be very brief. -4.36. In the year 1993, what is the difference between the CO2 emissions (% of total fuel combustion) of Morocco and CO2 emissions (% of total fuel combustion) of Nepal?
Your answer should be very brief. -14.79. In the year 1993, what is the difference between the CO2 emissions (% of total fuel combustion) in Morocco and CO2 emissions (% of total fuel combustion) in Slovenia?
Ensure brevity in your answer.  -0.65. In the year 1993, what is the difference between the CO2 emissions (% of total fuel combustion) of Nepal and CO2 emissions (% of total fuel combustion) of Slovenia?
Offer a terse response. 14.14. In the year 1994, what is the difference between the CO2 emissions (% of total fuel combustion) of Croatia and CO2 emissions (% of total fuel combustion) of Morocco?
Ensure brevity in your answer.  -1.32. In the year 1994, what is the difference between the CO2 emissions (% of total fuel combustion) in Croatia and CO2 emissions (% of total fuel combustion) in Nepal?
Your answer should be very brief. -13.33. In the year 1994, what is the difference between the CO2 emissions (% of total fuel combustion) in Croatia and CO2 emissions (% of total fuel combustion) in Slovenia?
Your response must be concise. -4.93. In the year 1994, what is the difference between the CO2 emissions (% of total fuel combustion) in Morocco and CO2 emissions (% of total fuel combustion) in Nepal?
Make the answer very short. -12.01. In the year 1994, what is the difference between the CO2 emissions (% of total fuel combustion) of Morocco and CO2 emissions (% of total fuel combustion) of Slovenia?
Your answer should be compact. -3.61. In the year 1994, what is the difference between the CO2 emissions (% of total fuel combustion) of Nepal and CO2 emissions (% of total fuel combustion) of Slovenia?
Your answer should be compact. 8.4. In the year 1995, what is the difference between the CO2 emissions (% of total fuel combustion) of Croatia and CO2 emissions (% of total fuel combustion) of Morocco?
Your response must be concise. -1.7. In the year 1995, what is the difference between the CO2 emissions (% of total fuel combustion) in Croatia and CO2 emissions (% of total fuel combustion) in Nepal?
Provide a succinct answer. -14.56. In the year 1995, what is the difference between the CO2 emissions (% of total fuel combustion) in Croatia and CO2 emissions (% of total fuel combustion) in Slovenia?
Your response must be concise. -6.01. In the year 1995, what is the difference between the CO2 emissions (% of total fuel combustion) of Morocco and CO2 emissions (% of total fuel combustion) of Nepal?
Your answer should be very brief. -12.85. In the year 1995, what is the difference between the CO2 emissions (% of total fuel combustion) of Morocco and CO2 emissions (% of total fuel combustion) of Slovenia?
Provide a succinct answer. -4.31. In the year 1995, what is the difference between the CO2 emissions (% of total fuel combustion) of Nepal and CO2 emissions (% of total fuel combustion) of Slovenia?
Your answer should be very brief. 8.55. In the year 1996, what is the difference between the CO2 emissions (% of total fuel combustion) in Croatia and CO2 emissions (% of total fuel combustion) in Morocco?
Make the answer very short. -2.18. In the year 1996, what is the difference between the CO2 emissions (% of total fuel combustion) in Croatia and CO2 emissions (% of total fuel combustion) in Nepal?
Offer a very short reply. -12.84. In the year 1996, what is the difference between the CO2 emissions (% of total fuel combustion) of Croatia and CO2 emissions (% of total fuel combustion) of Slovenia?
Your answer should be compact. -6.57. In the year 1996, what is the difference between the CO2 emissions (% of total fuel combustion) of Morocco and CO2 emissions (% of total fuel combustion) of Nepal?
Offer a terse response. -10.66. In the year 1996, what is the difference between the CO2 emissions (% of total fuel combustion) of Morocco and CO2 emissions (% of total fuel combustion) of Slovenia?
Offer a very short reply. -4.38. In the year 1996, what is the difference between the CO2 emissions (% of total fuel combustion) of Nepal and CO2 emissions (% of total fuel combustion) of Slovenia?
Provide a succinct answer. 6.28. In the year 1997, what is the difference between the CO2 emissions (% of total fuel combustion) of Croatia and CO2 emissions (% of total fuel combustion) of Morocco?
Provide a short and direct response. -2.26. In the year 1997, what is the difference between the CO2 emissions (% of total fuel combustion) in Croatia and CO2 emissions (% of total fuel combustion) in Nepal?
Give a very brief answer. -12.15. In the year 1997, what is the difference between the CO2 emissions (% of total fuel combustion) of Croatia and CO2 emissions (% of total fuel combustion) of Slovenia?
Provide a short and direct response. -6.68. In the year 1997, what is the difference between the CO2 emissions (% of total fuel combustion) in Morocco and CO2 emissions (% of total fuel combustion) in Nepal?
Your answer should be compact. -9.89. In the year 1997, what is the difference between the CO2 emissions (% of total fuel combustion) of Morocco and CO2 emissions (% of total fuel combustion) of Slovenia?
Give a very brief answer. -4.41. In the year 1997, what is the difference between the CO2 emissions (% of total fuel combustion) in Nepal and CO2 emissions (% of total fuel combustion) in Slovenia?
Give a very brief answer. 5.48. In the year 1998, what is the difference between the CO2 emissions (% of total fuel combustion) of Croatia and CO2 emissions (% of total fuel combustion) of Morocco?
Provide a succinct answer. -3.79. In the year 1998, what is the difference between the CO2 emissions (% of total fuel combustion) of Croatia and CO2 emissions (% of total fuel combustion) of Nepal?
Make the answer very short. -12.43. In the year 1998, what is the difference between the CO2 emissions (% of total fuel combustion) of Croatia and CO2 emissions (% of total fuel combustion) of Slovenia?
Ensure brevity in your answer.  -2.56. In the year 1998, what is the difference between the CO2 emissions (% of total fuel combustion) of Morocco and CO2 emissions (% of total fuel combustion) of Nepal?
Provide a short and direct response. -8.64. In the year 1998, what is the difference between the CO2 emissions (% of total fuel combustion) in Morocco and CO2 emissions (% of total fuel combustion) in Slovenia?
Give a very brief answer. 1.24. In the year 1998, what is the difference between the CO2 emissions (% of total fuel combustion) in Nepal and CO2 emissions (% of total fuel combustion) in Slovenia?
Make the answer very short. 9.88. What is the ratio of the CO2 emissions (% of total fuel combustion) in Morocco in 1991 to that in 1992?
Provide a succinct answer. 0.97. What is the ratio of the CO2 emissions (% of total fuel combustion) of Nepal in 1991 to that in 1992?
Ensure brevity in your answer.  0.94. What is the ratio of the CO2 emissions (% of total fuel combustion) of Slovenia in 1991 to that in 1992?
Give a very brief answer. 0.95. What is the ratio of the CO2 emissions (% of total fuel combustion) in Croatia in 1991 to that in 1993?
Offer a terse response. 0.99. What is the ratio of the CO2 emissions (% of total fuel combustion) of Morocco in 1991 to that in 1993?
Ensure brevity in your answer.  0.91. What is the ratio of the CO2 emissions (% of total fuel combustion) of Slovenia in 1991 to that in 1993?
Ensure brevity in your answer.  0.83. What is the ratio of the CO2 emissions (% of total fuel combustion) of Croatia in 1991 to that in 1994?
Your response must be concise. 0.89. What is the ratio of the CO2 emissions (% of total fuel combustion) in Morocco in 1991 to that in 1994?
Your response must be concise. 0.93. What is the ratio of the CO2 emissions (% of total fuel combustion) of Nepal in 1991 to that in 1994?
Your answer should be very brief. 1.05. What is the ratio of the CO2 emissions (% of total fuel combustion) of Slovenia in 1991 to that in 1994?
Ensure brevity in your answer.  0.75. What is the ratio of the CO2 emissions (% of total fuel combustion) in Croatia in 1991 to that in 1995?
Make the answer very short. 0.89. What is the ratio of the CO2 emissions (% of total fuel combustion) of Morocco in 1991 to that in 1995?
Make the answer very short. 0.91. What is the ratio of the CO2 emissions (% of total fuel combustion) of Nepal in 1991 to that in 1995?
Make the answer very short. 1.01. What is the ratio of the CO2 emissions (% of total fuel combustion) in Slovenia in 1991 to that in 1995?
Your response must be concise. 0.72. What is the ratio of the CO2 emissions (% of total fuel combustion) of Croatia in 1991 to that in 1996?
Provide a succinct answer. 0.83. What is the ratio of the CO2 emissions (% of total fuel combustion) in Morocco in 1991 to that in 1996?
Ensure brevity in your answer.  0.84. What is the ratio of the CO2 emissions (% of total fuel combustion) in Nepal in 1991 to that in 1996?
Offer a very short reply. 1.02. What is the ratio of the CO2 emissions (% of total fuel combustion) of Slovenia in 1991 to that in 1996?
Make the answer very short. 0.67. What is the ratio of the CO2 emissions (% of total fuel combustion) in Croatia in 1991 to that in 1997?
Your answer should be very brief. 0.82. What is the ratio of the CO2 emissions (% of total fuel combustion) in Morocco in 1991 to that in 1997?
Give a very brief answer. 0.82. What is the ratio of the CO2 emissions (% of total fuel combustion) in Nepal in 1991 to that in 1997?
Ensure brevity in your answer.  1.03. What is the ratio of the CO2 emissions (% of total fuel combustion) in Slovenia in 1991 to that in 1997?
Your answer should be compact. 0.66. What is the ratio of the CO2 emissions (% of total fuel combustion) of Croatia in 1991 to that in 1998?
Make the answer very short. 0.84. What is the ratio of the CO2 emissions (% of total fuel combustion) in Morocco in 1991 to that in 1998?
Your answer should be very brief. 0.79. What is the ratio of the CO2 emissions (% of total fuel combustion) of Nepal in 1991 to that in 1998?
Provide a succinct answer. 1.03. What is the ratio of the CO2 emissions (% of total fuel combustion) of Slovenia in 1991 to that in 1998?
Give a very brief answer. 0.78. What is the ratio of the CO2 emissions (% of total fuel combustion) in Croatia in 1992 to that in 1993?
Your answer should be compact. 0.98. What is the ratio of the CO2 emissions (% of total fuel combustion) in Morocco in 1992 to that in 1993?
Provide a succinct answer. 0.94. What is the ratio of the CO2 emissions (% of total fuel combustion) in Nepal in 1992 to that in 1993?
Offer a terse response. 1.02. What is the ratio of the CO2 emissions (% of total fuel combustion) of Slovenia in 1992 to that in 1993?
Provide a succinct answer. 0.88. What is the ratio of the CO2 emissions (% of total fuel combustion) of Croatia in 1992 to that in 1994?
Ensure brevity in your answer.  0.89. What is the ratio of the CO2 emissions (% of total fuel combustion) in Morocco in 1992 to that in 1994?
Give a very brief answer. 0.96. What is the ratio of the CO2 emissions (% of total fuel combustion) in Nepal in 1992 to that in 1994?
Make the answer very short. 1.12. What is the ratio of the CO2 emissions (% of total fuel combustion) of Slovenia in 1992 to that in 1994?
Keep it short and to the point. 0.79. What is the ratio of the CO2 emissions (% of total fuel combustion) of Croatia in 1992 to that in 1995?
Keep it short and to the point. 0.89. What is the ratio of the CO2 emissions (% of total fuel combustion) of Morocco in 1992 to that in 1995?
Ensure brevity in your answer.  0.94. What is the ratio of the CO2 emissions (% of total fuel combustion) of Nepal in 1992 to that in 1995?
Keep it short and to the point. 1.08. What is the ratio of the CO2 emissions (% of total fuel combustion) in Slovenia in 1992 to that in 1995?
Provide a succinct answer. 0.76. What is the ratio of the CO2 emissions (% of total fuel combustion) of Croatia in 1992 to that in 1996?
Provide a short and direct response. 0.83. What is the ratio of the CO2 emissions (% of total fuel combustion) in Morocco in 1992 to that in 1996?
Your response must be concise. 0.87. What is the ratio of the CO2 emissions (% of total fuel combustion) of Nepal in 1992 to that in 1996?
Make the answer very short. 1.09. What is the ratio of the CO2 emissions (% of total fuel combustion) of Slovenia in 1992 to that in 1996?
Provide a short and direct response. 0.71. What is the ratio of the CO2 emissions (% of total fuel combustion) in Croatia in 1992 to that in 1997?
Your response must be concise. 0.81. What is the ratio of the CO2 emissions (% of total fuel combustion) of Morocco in 1992 to that in 1997?
Give a very brief answer. 0.85. What is the ratio of the CO2 emissions (% of total fuel combustion) of Nepal in 1992 to that in 1997?
Keep it short and to the point. 1.09. What is the ratio of the CO2 emissions (% of total fuel combustion) of Slovenia in 1992 to that in 1997?
Give a very brief answer. 0.7. What is the ratio of the CO2 emissions (% of total fuel combustion) in Croatia in 1992 to that in 1998?
Make the answer very short. 0.83. What is the ratio of the CO2 emissions (% of total fuel combustion) in Morocco in 1992 to that in 1998?
Your response must be concise. 0.82. What is the ratio of the CO2 emissions (% of total fuel combustion) in Nepal in 1992 to that in 1998?
Offer a terse response. 1.1. What is the ratio of the CO2 emissions (% of total fuel combustion) of Slovenia in 1992 to that in 1998?
Ensure brevity in your answer.  0.82. What is the ratio of the CO2 emissions (% of total fuel combustion) of Croatia in 1993 to that in 1994?
Provide a succinct answer. 0.9. What is the ratio of the CO2 emissions (% of total fuel combustion) of Morocco in 1993 to that in 1994?
Your answer should be very brief. 1.02. What is the ratio of the CO2 emissions (% of total fuel combustion) in Nepal in 1993 to that in 1994?
Offer a very short reply. 1.09. What is the ratio of the CO2 emissions (% of total fuel combustion) of Slovenia in 1993 to that in 1994?
Keep it short and to the point. 0.9. What is the ratio of the CO2 emissions (% of total fuel combustion) in Croatia in 1993 to that in 1995?
Give a very brief answer. 0.9. What is the ratio of the CO2 emissions (% of total fuel combustion) in Morocco in 1993 to that in 1995?
Provide a short and direct response. 1. What is the ratio of the CO2 emissions (% of total fuel combustion) of Nepal in 1993 to that in 1995?
Offer a very short reply. 1.05. What is the ratio of the CO2 emissions (% of total fuel combustion) in Slovenia in 1993 to that in 1995?
Give a very brief answer. 0.86. What is the ratio of the CO2 emissions (% of total fuel combustion) in Croatia in 1993 to that in 1996?
Provide a succinct answer. 0.84. What is the ratio of the CO2 emissions (% of total fuel combustion) of Morocco in 1993 to that in 1996?
Offer a terse response. 0.92. What is the ratio of the CO2 emissions (% of total fuel combustion) of Nepal in 1993 to that in 1996?
Your response must be concise. 1.06. What is the ratio of the CO2 emissions (% of total fuel combustion) in Slovenia in 1993 to that in 1996?
Your answer should be very brief. 0.8. What is the ratio of the CO2 emissions (% of total fuel combustion) of Croatia in 1993 to that in 1997?
Your answer should be compact. 0.83. What is the ratio of the CO2 emissions (% of total fuel combustion) of Morocco in 1993 to that in 1997?
Provide a succinct answer. 0.9. What is the ratio of the CO2 emissions (% of total fuel combustion) in Nepal in 1993 to that in 1997?
Make the answer very short. 1.07. What is the ratio of the CO2 emissions (% of total fuel combustion) of Slovenia in 1993 to that in 1997?
Provide a succinct answer. 0.79. What is the ratio of the CO2 emissions (% of total fuel combustion) of Croatia in 1993 to that in 1998?
Offer a terse response. 0.85. What is the ratio of the CO2 emissions (% of total fuel combustion) in Morocco in 1993 to that in 1998?
Keep it short and to the point. 0.87. What is the ratio of the CO2 emissions (% of total fuel combustion) in Nepal in 1993 to that in 1998?
Give a very brief answer. 1.08. What is the ratio of the CO2 emissions (% of total fuel combustion) of Slovenia in 1993 to that in 1998?
Your response must be concise. 0.94. What is the ratio of the CO2 emissions (% of total fuel combustion) of Morocco in 1994 to that in 1995?
Offer a very short reply. 0.98. What is the ratio of the CO2 emissions (% of total fuel combustion) of Nepal in 1994 to that in 1995?
Give a very brief answer. 0.96. What is the ratio of the CO2 emissions (% of total fuel combustion) of Slovenia in 1994 to that in 1995?
Provide a short and direct response. 0.96. What is the ratio of the CO2 emissions (% of total fuel combustion) in Croatia in 1994 to that in 1996?
Your response must be concise. 0.93. What is the ratio of the CO2 emissions (% of total fuel combustion) in Morocco in 1994 to that in 1996?
Keep it short and to the point. 0.91. What is the ratio of the CO2 emissions (% of total fuel combustion) in Nepal in 1994 to that in 1996?
Provide a short and direct response. 0.97. What is the ratio of the CO2 emissions (% of total fuel combustion) in Slovenia in 1994 to that in 1996?
Your answer should be compact. 0.89. What is the ratio of the CO2 emissions (% of total fuel combustion) in Croatia in 1994 to that in 1997?
Your answer should be compact. 0.92. What is the ratio of the CO2 emissions (% of total fuel combustion) of Morocco in 1994 to that in 1997?
Offer a terse response. 0.89. What is the ratio of the CO2 emissions (% of total fuel combustion) of Nepal in 1994 to that in 1997?
Provide a short and direct response. 0.98. What is the ratio of the CO2 emissions (% of total fuel combustion) of Slovenia in 1994 to that in 1997?
Offer a very short reply. 0.88. What is the ratio of the CO2 emissions (% of total fuel combustion) of Croatia in 1994 to that in 1998?
Provide a succinct answer. 0.94. What is the ratio of the CO2 emissions (% of total fuel combustion) in Morocco in 1994 to that in 1998?
Provide a succinct answer. 0.85. What is the ratio of the CO2 emissions (% of total fuel combustion) in Slovenia in 1994 to that in 1998?
Your answer should be compact. 1.04. What is the ratio of the CO2 emissions (% of total fuel combustion) in Croatia in 1995 to that in 1996?
Offer a very short reply. 0.94. What is the ratio of the CO2 emissions (% of total fuel combustion) of Morocco in 1995 to that in 1996?
Provide a short and direct response. 0.92. What is the ratio of the CO2 emissions (% of total fuel combustion) in Nepal in 1995 to that in 1996?
Ensure brevity in your answer.  1.01. What is the ratio of the CO2 emissions (% of total fuel combustion) of Slovenia in 1995 to that in 1996?
Ensure brevity in your answer.  0.93. What is the ratio of the CO2 emissions (% of total fuel combustion) of Croatia in 1995 to that in 1997?
Your response must be concise. 0.92. What is the ratio of the CO2 emissions (% of total fuel combustion) in Morocco in 1995 to that in 1997?
Offer a terse response. 0.9. What is the ratio of the CO2 emissions (% of total fuel combustion) in Nepal in 1995 to that in 1997?
Your answer should be very brief. 1.02. What is the ratio of the CO2 emissions (% of total fuel combustion) of Slovenia in 1995 to that in 1997?
Your response must be concise. 0.91. What is the ratio of the CO2 emissions (% of total fuel combustion) in Croatia in 1995 to that in 1998?
Keep it short and to the point. 0.94. What is the ratio of the CO2 emissions (% of total fuel combustion) of Morocco in 1995 to that in 1998?
Ensure brevity in your answer.  0.87. What is the ratio of the CO2 emissions (% of total fuel combustion) of Nepal in 1995 to that in 1998?
Provide a short and direct response. 1.02. What is the ratio of the CO2 emissions (% of total fuel combustion) of Slovenia in 1995 to that in 1998?
Your answer should be compact. 1.08. What is the ratio of the CO2 emissions (% of total fuel combustion) of Croatia in 1996 to that in 1997?
Provide a short and direct response. 0.98. What is the ratio of the CO2 emissions (% of total fuel combustion) of Morocco in 1996 to that in 1997?
Your response must be concise. 0.98. What is the ratio of the CO2 emissions (% of total fuel combustion) in Nepal in 1996 to that in 1997?
Ensure brevity in your answer.  1.01. What is the ratio of the CO2 emissions (% of total fuel combustion) in Slovenia in 1996 to that in 1997?
Keep it short and to the point. 0.98. What is the ratio of the CO2 emissions (% of total fuel combustion) in Croatia in 1996 to that in 1998?
Your answer should be compact. 1. What is the ratio of the CO2 emissions (% of total fuel combustion) of Morocco in 1996 to that in 1998?
Keep it short and to the point. 0.94. What is the ratio of the CO2 emissions (% of total fuel combustion) of Nepal in 1996 to that in 1998?
Your answer should be compact. 1.01. What is the ratio of the CO2 emissions (% of total fuel combustion) of Slovenia in 1996 to that in 1998?
Provide a succinct answer. 1.16. What is the ratio of the CO2 emissions (% of total fuel combustion) in Morocco in 1997 to that in 1998?
Your answer should be compact. 0.96. What is the ratio of the CO2 emissions (% of total fuel combustion) of Slovenia in 1997 to that in 1998?
Offer a very short reply. 1.19. What is the difference between the highest and the second highest CO2 emissions (% of total fuel combustion) in Croatia?
Give a very brief answer. 0.43. What is the difference between the highest and the second highest CO2 emissions (% of total fuel combustion) in Morocco?
Offer a very short reply. 1.02. What is the difference between the highest and the second highest CO2 emissions (% of total fuel combustion) in Nepal?
Give a very brief answer. 0.89. What is the difference between the highest and the second highest CO2 emissions (% of total fuel combustion) in Slovenia?
Offer a very short reply. 0.54. What is the difference between the highest and the lowest CO2 emissions (% of total fuel combustion) of Croatia?
Give a very brief answer. 4.29. What is the difference between the highest and the lowest CO2 emissions (% of total fuel combustion) in Morocco?
Your answer should be very brief. 5.48. What is the difference between the highest and the lowest CO2 emissions (% of total fuel combustion) of Nepal?
Keep it short and to the point. 4.02. What is the difference between the highest and the lowest CO2 emissions (% of total fuel combustion) in Slovenia?
Your response must be concise. 10.14. 